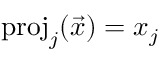<formula> <loc_0><loc_0><loc_500><loc_500>p r o j _ { j } ( { \vec { x } } ) = x _ { j }</formula> 